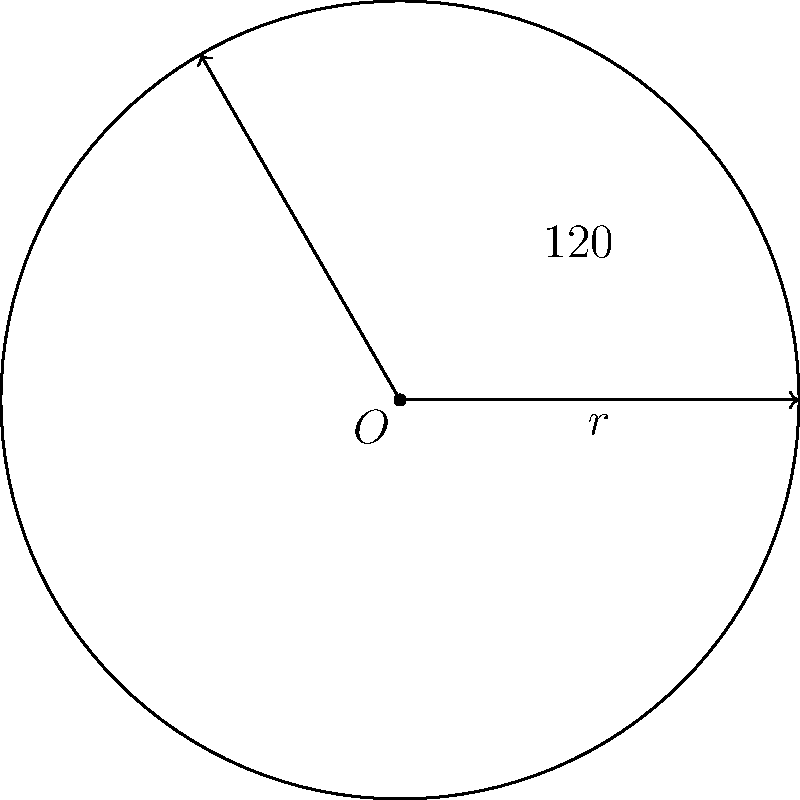In a circular medication dispensing system, the central angle of a sector represents the time allocated for a specific medication. If the radius of the system is 30 cm and the central angle for a particular medication is 120°, what is the area of the sector representing this medication's time slot? To find the area of a circular sector, we can follow these steps:

1) The formula for the area of a circular sector is:
   
   $$A = \frac{1}{2}r^2\theta$$

   where $A$ is the area, $r$ is the radius, and $\theta$ is the central angle in radians.

2) We are given the radius $r = 30$ cm and the central angle of 120°.

3) We need to convert the angle from degrees to radians:
   
   $$\theta = 120° \times \frac{\pi}{180°} = \frac{2\pi}{3}$$ radians

4) Now we can substitute these values into our formula:

   $$A = \frac{1}{2} \times 30^2 \times \frac{2\pi}{3}$$

5) Simplify:
   
   $$A = \frac{1}{2} \times 900 \times \frac{2\pi}{3} = 300\pi$$ cm²

Therefore, the area of the sector is $300\pi$ square centimeters.
Answer: $300\pi$ cm² 